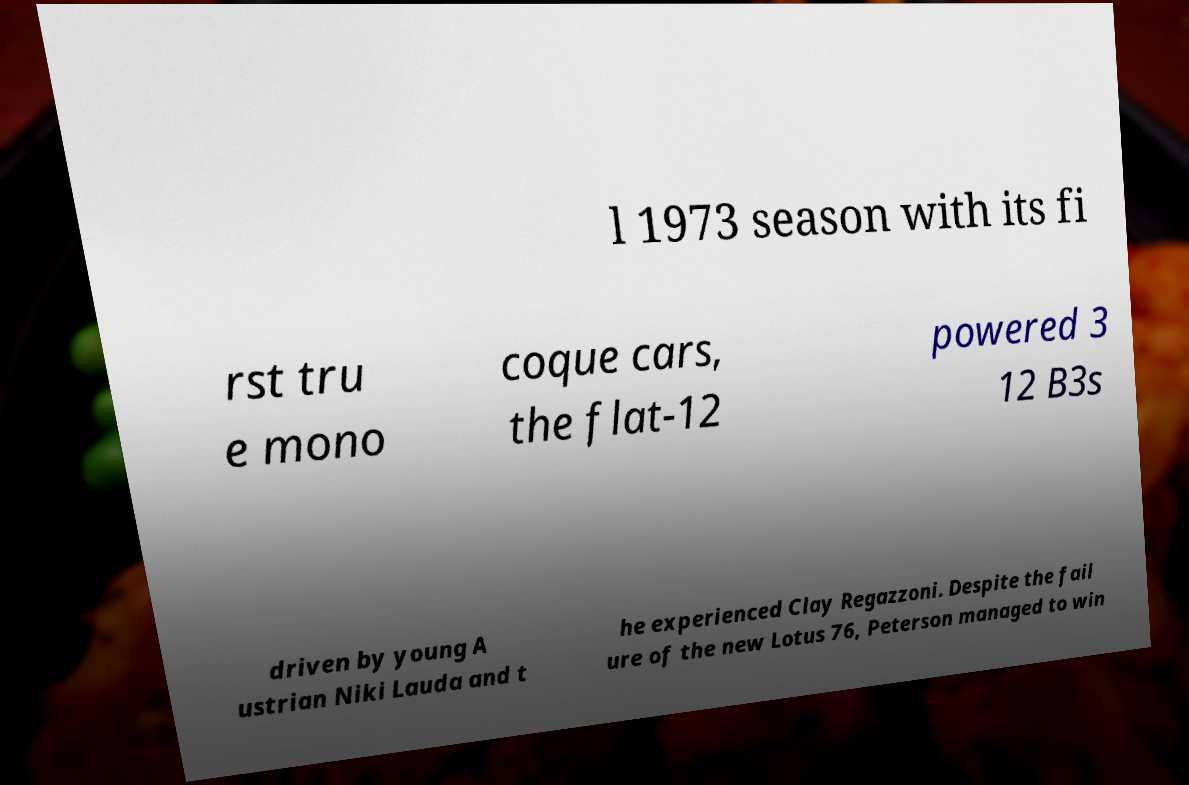Could you extract and type out the text from this image? l 1973 season with its fi rst tru e mono coque cars, the flat-12 powered 3 12 B3s driven by young A ustrian Niki Lauda and t he experienced Clay Regazzoni. Despite the fail ure of the new Lotus 76, Peterson managed to win 